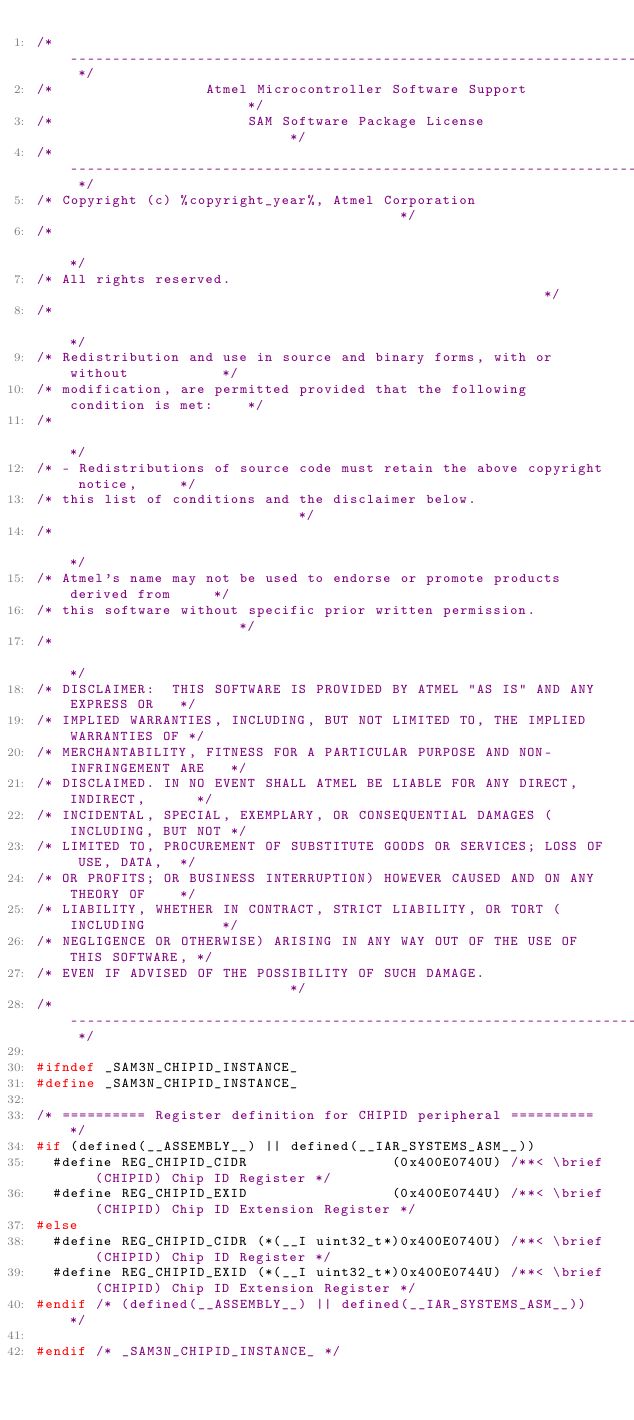Convert code to text. <code><loc_0><loc_0><loc_500><loc_500><_C_>/* ---------------------------------------------------------------------------- */
/*                  Atmel Microcontroller Software Support                      */
/*                       SAM Software Package License                           */
/* ---------------------------------------------------------------------------- */
/* Copyright (c) %copyright_year%, Atmel Corporation                                        */
/*                                                                              */
/* All rights reserved.                                                         */
/*                                                                              */
/* Redistribution and use in source and binary forms, with or without           */
/* modification, are permitted provided that the following condition is met:    */
/*                                                                              */
/* - Redistributions of source code must retain the above copyright notice,     */
/* this list of conditions and the disclaimer below.                            */
/*                                                                              */
/* Atmel's name may not be used to endorse or promote products derived from     */
/* this software without specific prior written permission.                     */
/*                                                                              */
/* DISCLAIMER:  THIS SOFTWARE IS PROVIDED BY ATMEL "AS IS" AND ANY EXPRESS OR   */
/* IMPLIED WARRANTIES, INCLUDING, BUT NOT LIMITED TO, THE IMPLIED WARRANTIES OF */
/* MERCHANTABILITY, FITNESS FOR A PARTICULAR PURPOSE AND NON-INFRINGEMENT ARE   */
/* DISCLAIMED. IN NO EVENT SHALL ATMEL BE LIABLE FOR ANY DIRECT, INDIRECT,      */
/* INCIDENTAL, SPECIAL, EXEMPLARY, OR CONSEQUENTIAL DAMAGES (INCLUDING, BUT NOT */
/* LIMITED TO, PROCUREMENT OF SUBSTITUTE GOODS OR SERVICES; LOSS OF USE, DATA,  */
/* OR PROFITS; OR BUSINESS INTERRUPTION) HOWEVER CAUSED AND ON ANY THEORY OF    */
/* LIABILITY, WHETHER IN CONTRACT, STRICT LIABILITY, OR TORT (INCLUDING         */
/* NEGLIGENCE OR OTHERWISE) ARISING IN ANY WAY OUT OF THE USE OF THIS SOFTWARE, */
/* EVEN IF ADVISED OF THE POSSIBILITY OF SUCH DAMAGE.                           */
/* ---------------------------------------------------------------------------- */

#ifndef _SAM3N_CHIPID_INSTANCE_
#define _SAM3N_CHIPID_INSTANCE_

/* ========== Register definition for CHIPID peripheral ========== */
#if (defined(__ASSEMBLY__) || defined(__IAR_SYSTEMS_ASM__))
  #define REG_CHIPID_CIDR                 (0x400E0740U) /**< \brief (CHIPID) Chip ID Register */
  #define REG_CHIPID_EXID                 (0x400E0744U) /**< \brief (CHIPID) Chip ID Extension Register */
#else
  #define REG_CHIPID_CIDR (*(__I uint32_t*)0x400E0740U) /**< \brief (CHIPID) Chip ID Register */
  #define REG_CHIPID_EXID (*(__I uint32_t*)0x400E0744U) /**< \brief (CHIPID) Chip ID Extension Register */
#endif /* (defined(__ASSEMBLY__) || defined(__IAR_SYSTEMS_ASM__)) */

#endif /* _SAM3N_CHIPID_INSTANCE_ */
</code> 